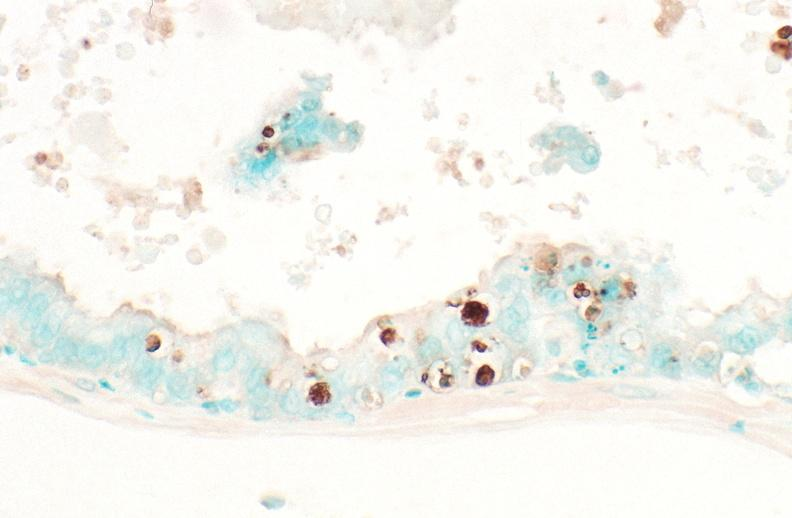does this image show prostate?
Answer the question using a single word or phrase. Yes 